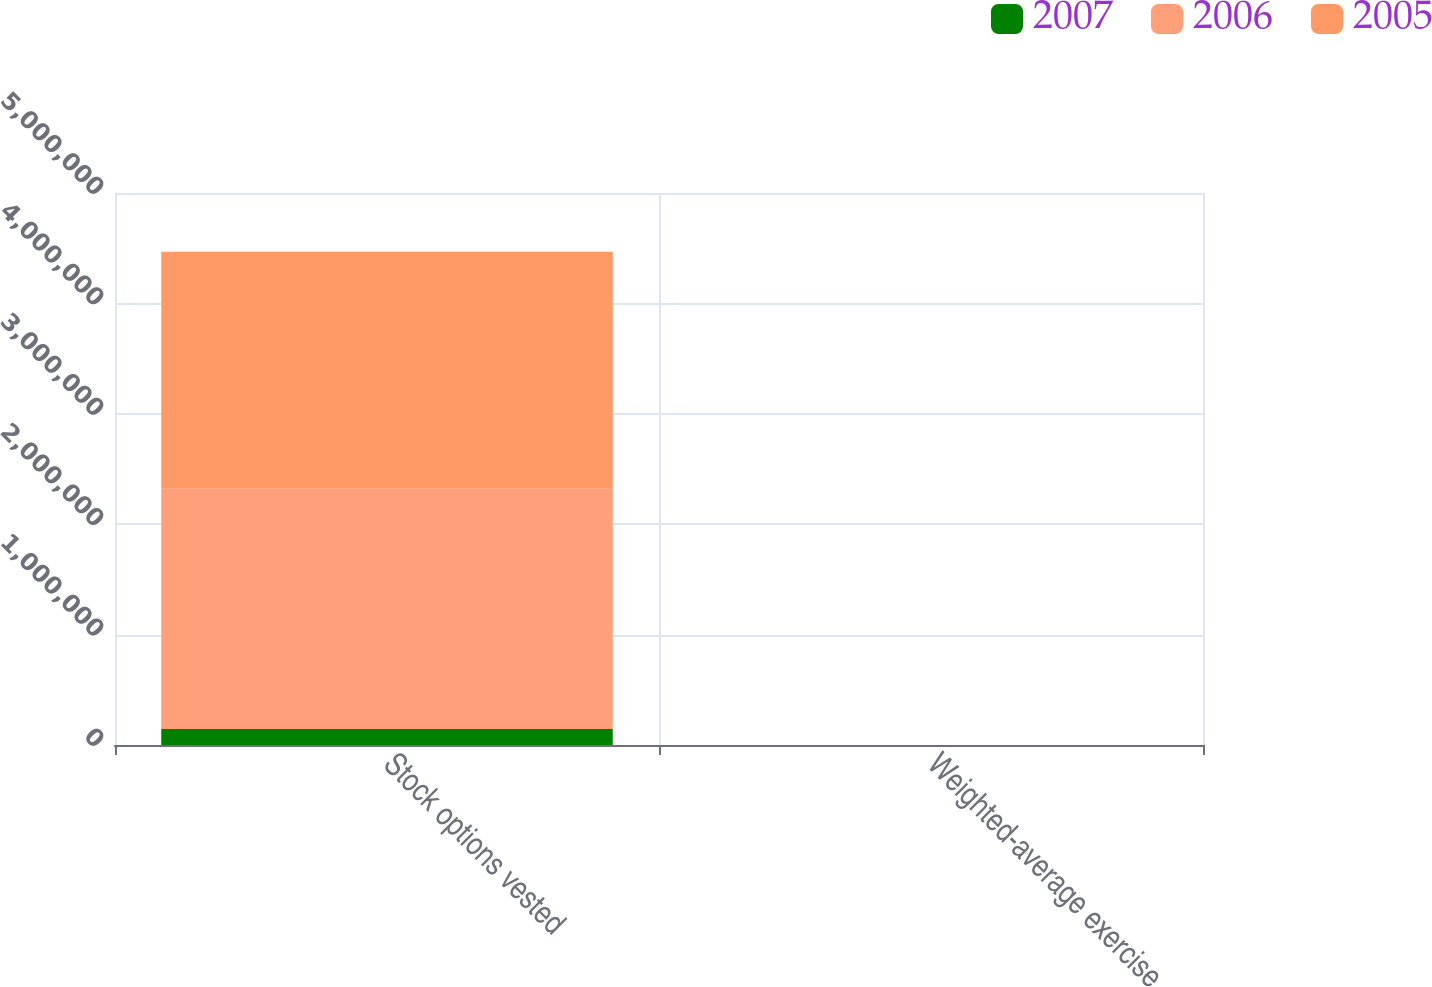Convert chart. <chart><loc_0><loc_0><loc_500><loc_500><stacked_bar_chart><ecel><fcel>Stock options vested<fcel>Weighted-average exercise<nl><fcel>2007<fcel>144726<fcel>46.92<nl><fcel>2006<fcel>2.17531e+06<fcel>40.1<nl><fcel>2005<fcel>2.14748e+06<fcel>38.55<nl></chart> 